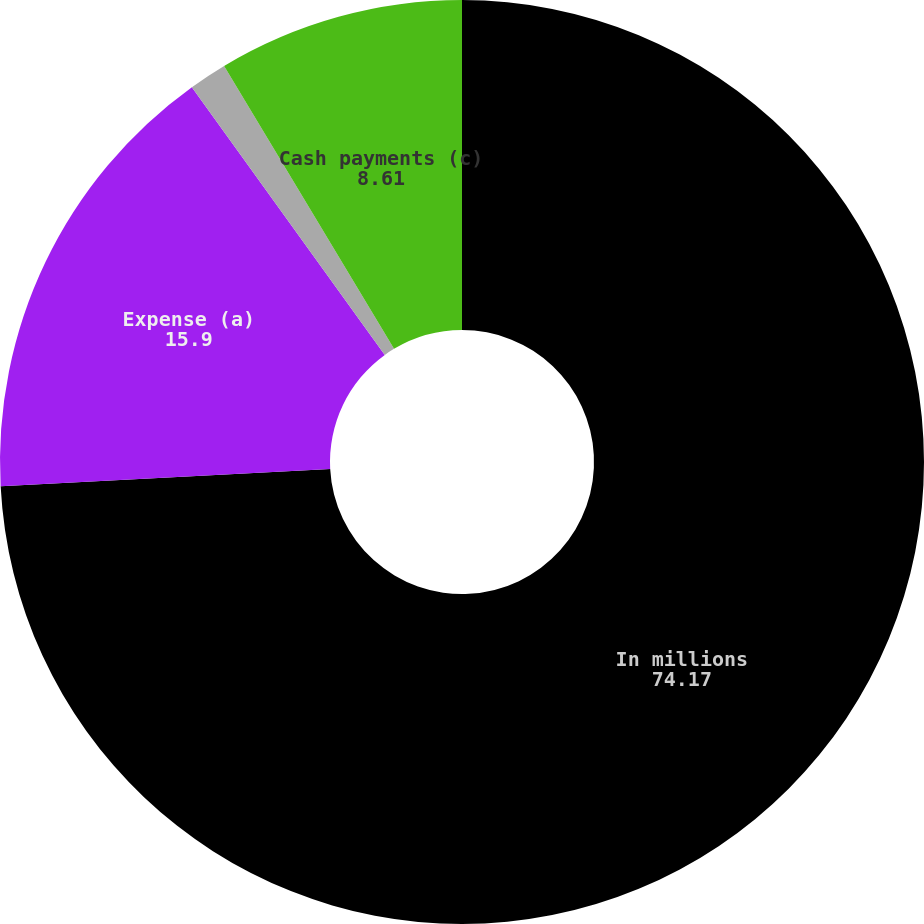Convert chart. <chart><loc_0><loc_0><loc_500><loc_500><pie_chart><fcel>In millions<fcel>Expense (a)<fcel>Cash receipts (b)<fcel>Cash payments (c)<nl><fcel>74.17%<fcel>15.9%<fcel>1.33%<fcel>8.61%<nl></chart> 